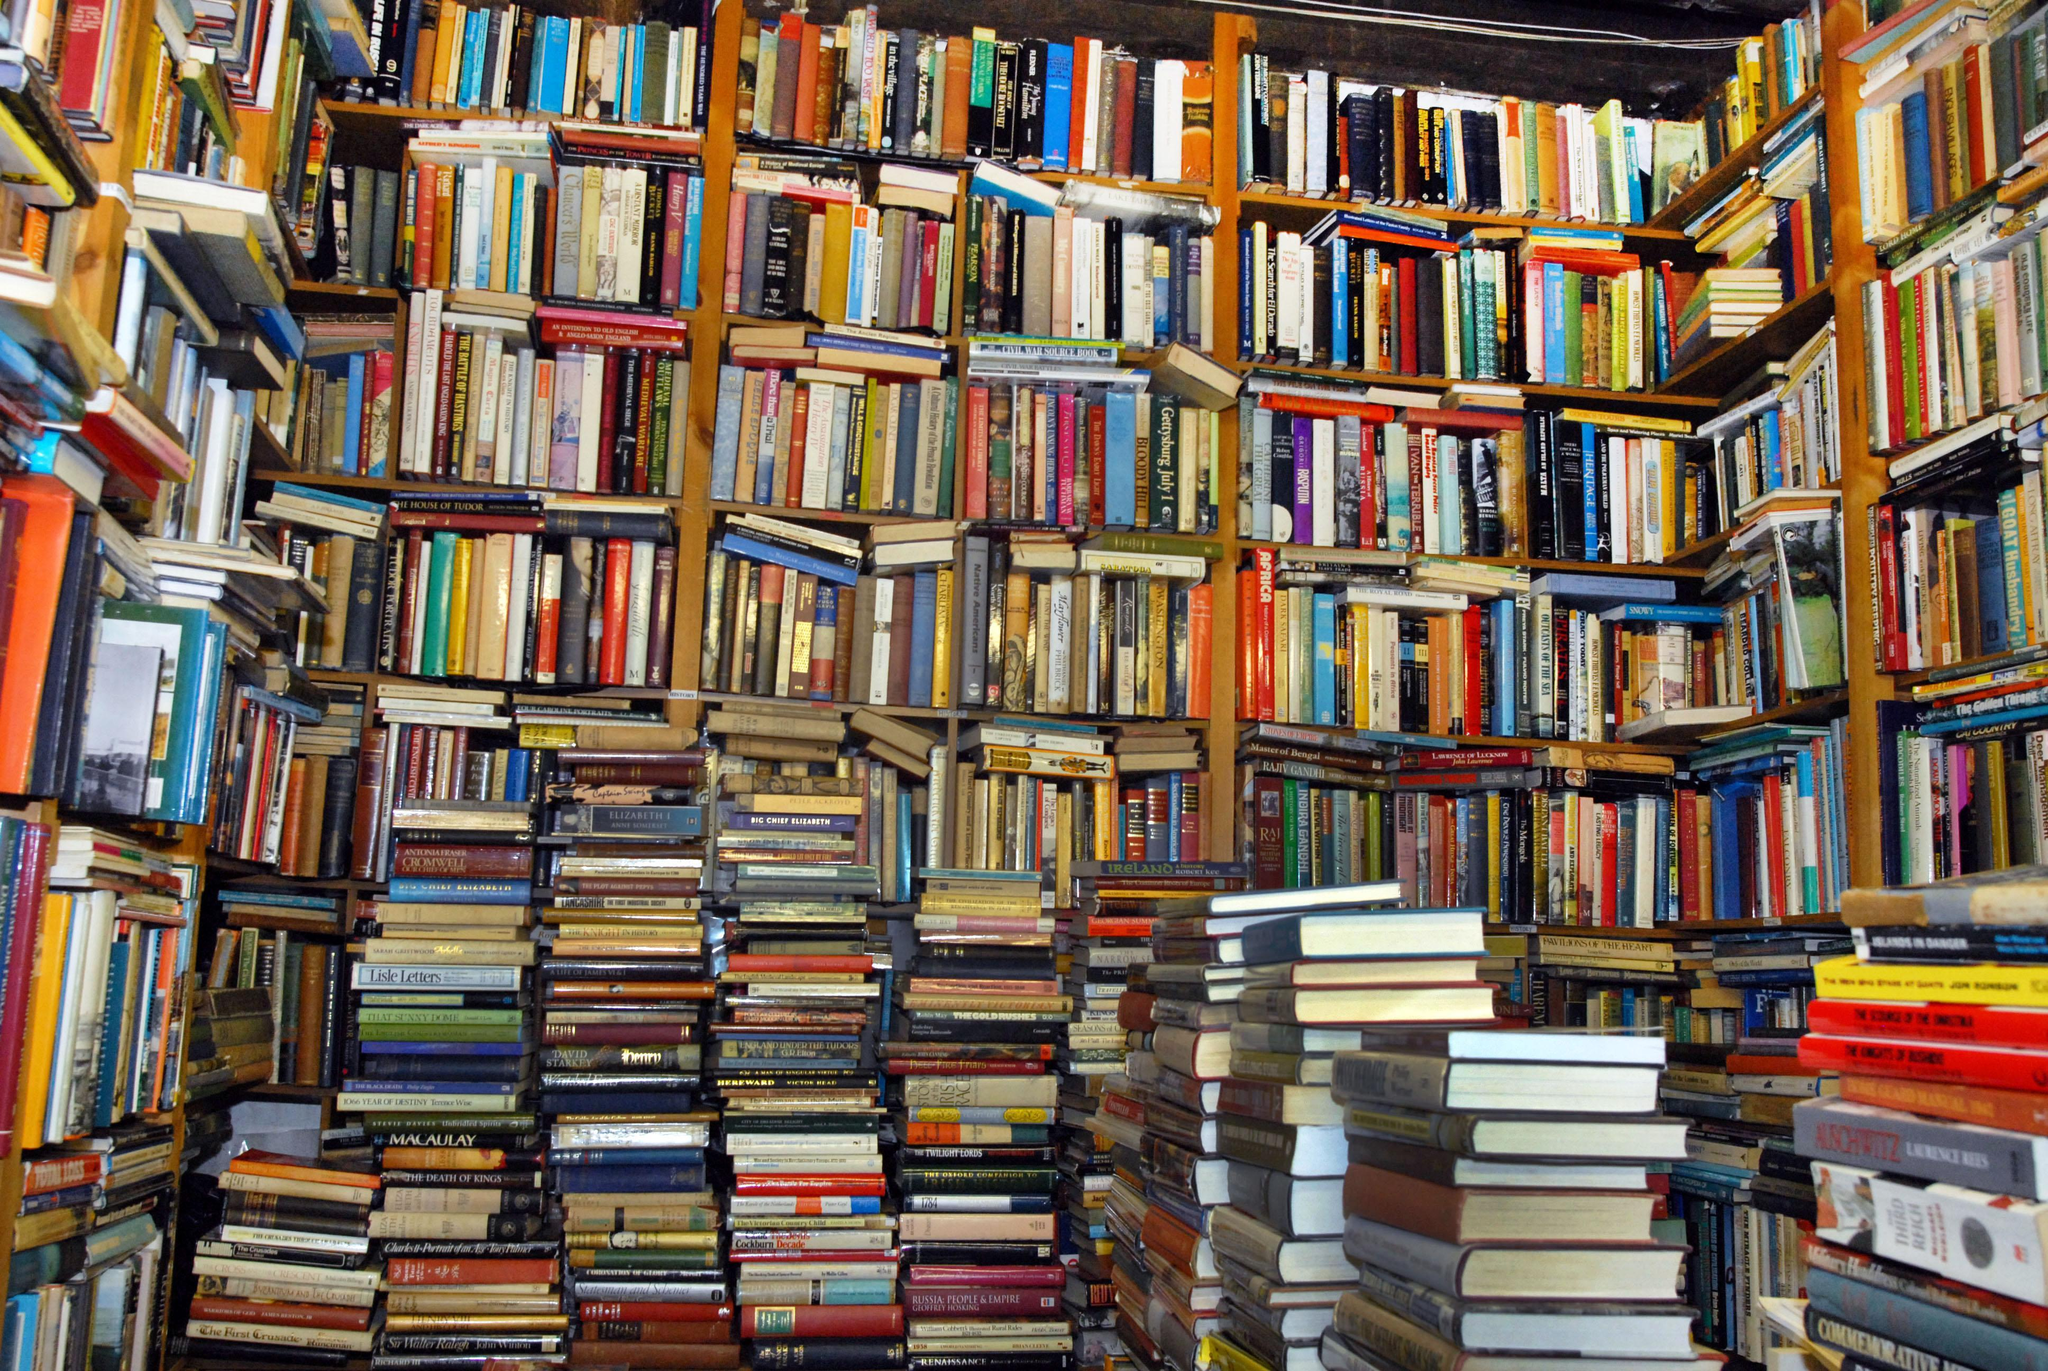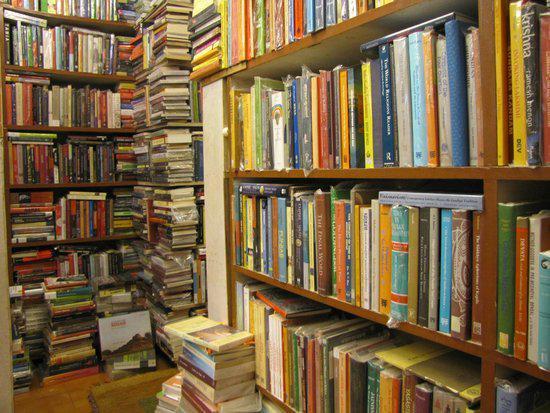The first image is the image on the left, the second image is the image on the right. Considering the images on both sides, is "A person poses for their picture in the left image." valid? Answer yes or no. No. The first image is the image on the left, the second image is the image on the right. Given the left and right images, does the statement "There is atleast two people in the photo" hold true? Answer yes or no. No. 